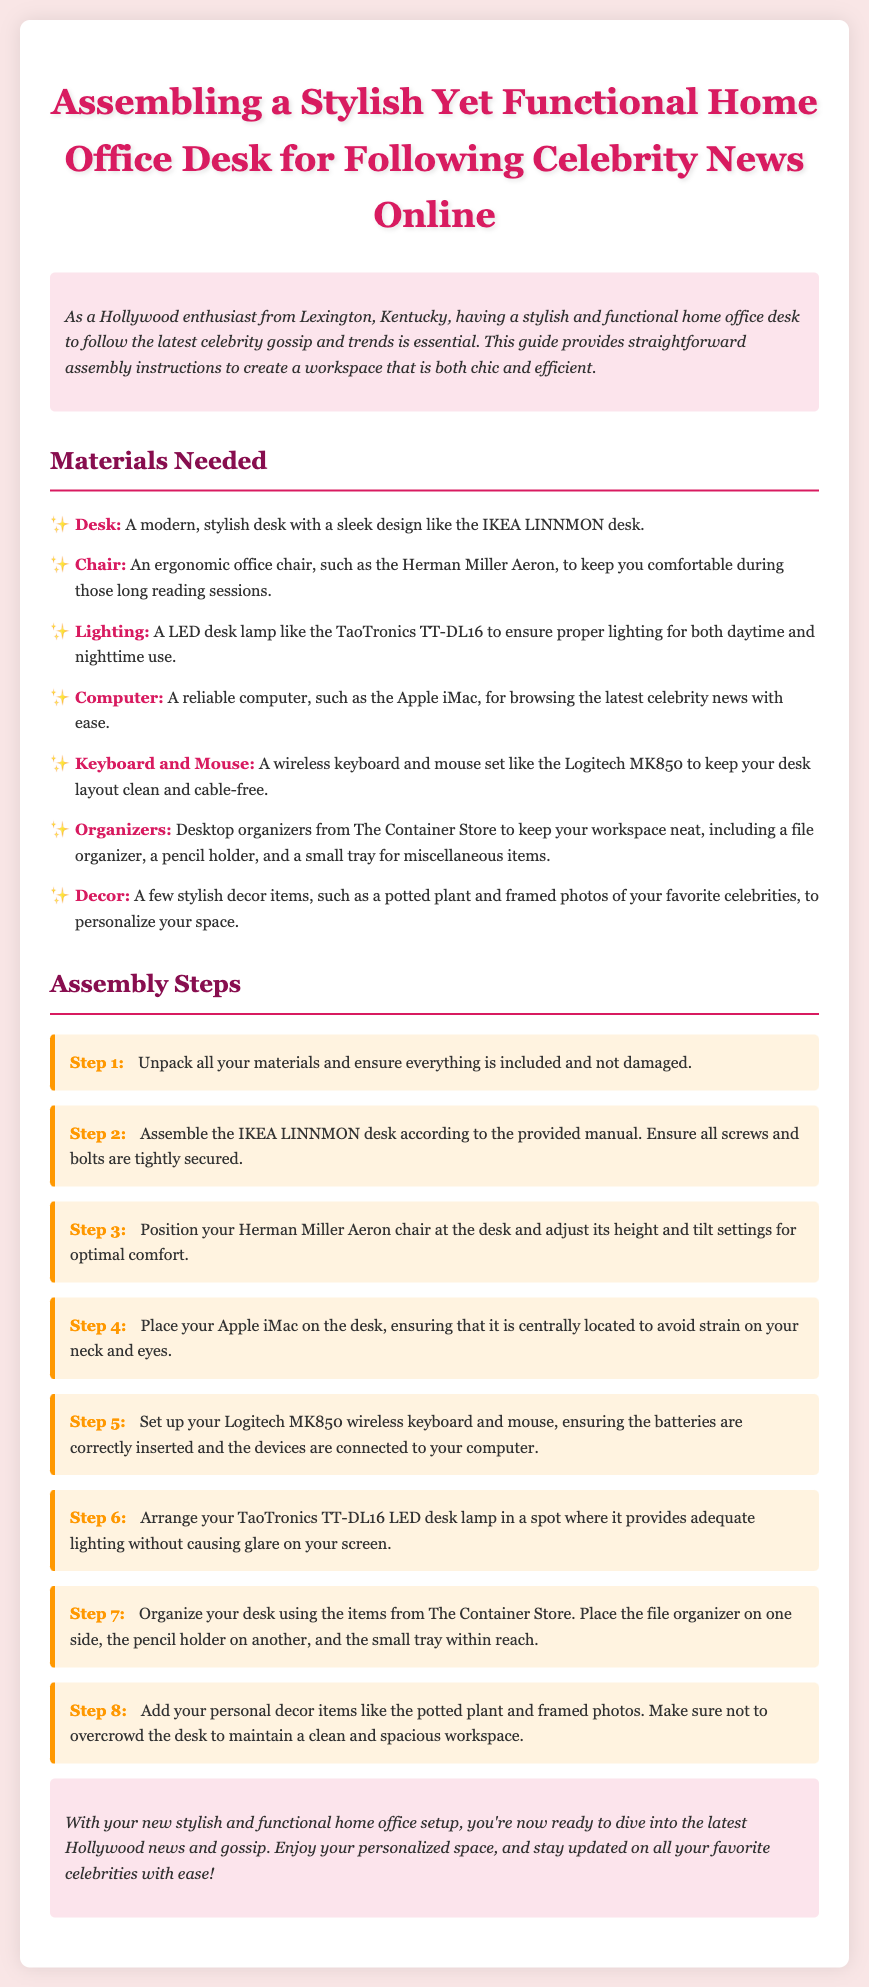What is the title of the document? The title is mentioned at the beginning of the document, indicating the purpose of the assembly instructions.
Answer: Assembling a Stylish Yet Functional Home Office Desk for Following Celebrity News Online What chair is recommended for comfort? The document suggests a specific ergonomic office chair for comfort during long sessions.
Answer: Herman Miller Aeron Which desk model is mentioned? The model of the desk is included in the list of materials needed for assembly.
Answer: IKEA LINNMON How many assembly steps are there? By counting the steps provided in the assembly section, the total number of steps is determined.
Answer: 8 What type of lighting is suggested? The lighting recommendation is listed to ensure proper illumination while working.
Answer: LED desk lamp Which organizers are recommended? The document specifies where to buy the organizers needed to keep the workspace tidy.
Answer: The Container Store What is the first step in assembling the desk? The first step outlines what to do with the unpacked materials to ensure everything is ready for assembly.
Answer: Unpack all your materials and ensure everything is included and not damaged What should you avoid when adding decor? The document gives advice on how to manage your desk decor to maintain a functional workspace.
Answer: Overcrowd the desk 